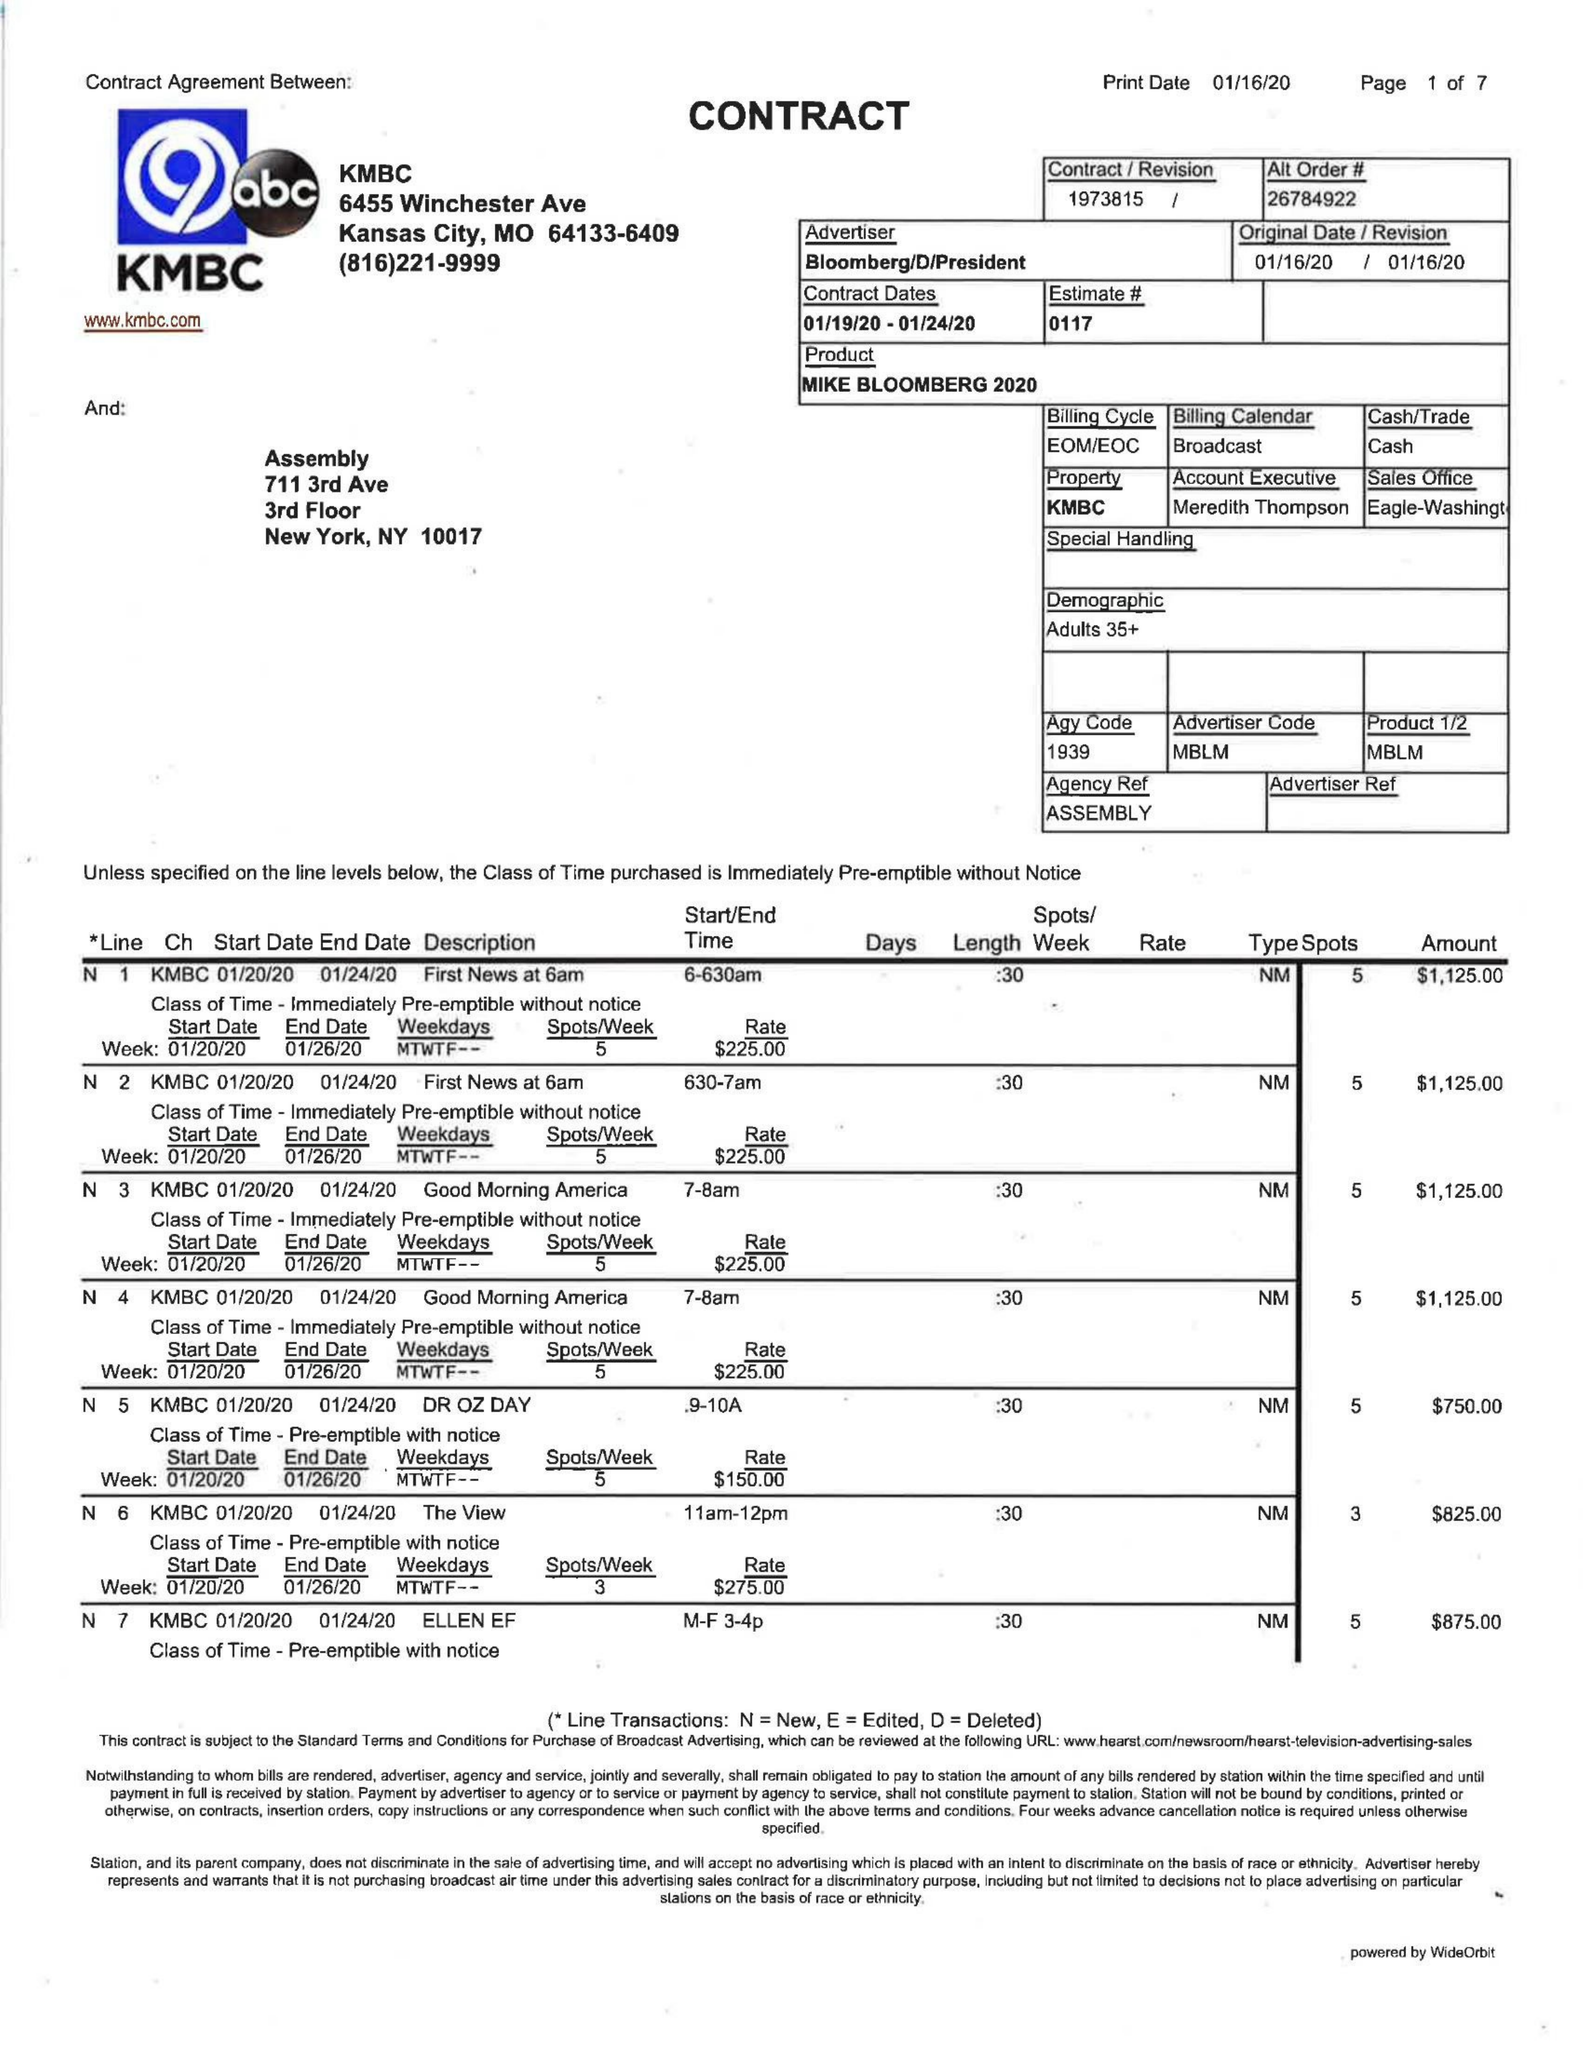What is the value for the contract_num?
Answer the question using a single word or phrase. 1973815 